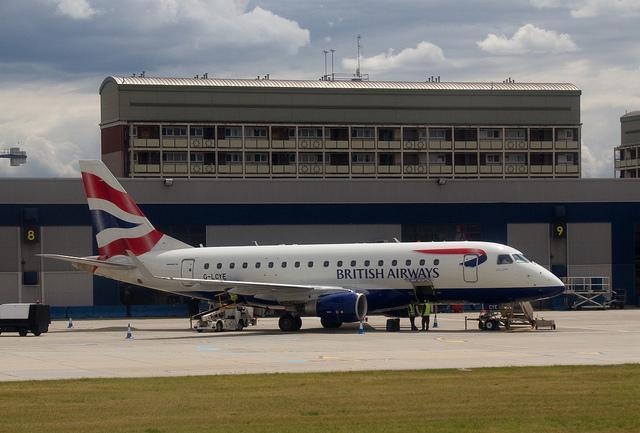What actress was born in the country where the plane comes from?
Select the correct answer and articulate reasoning with the following format: 'Answer: answer
Rationale: rationale.'
Options: Jessica biel, margaret qualley, kate beckinsale, lucy hale. Answer: kate beckinsale.
Rationale: She is from england and this is an airline for that country 